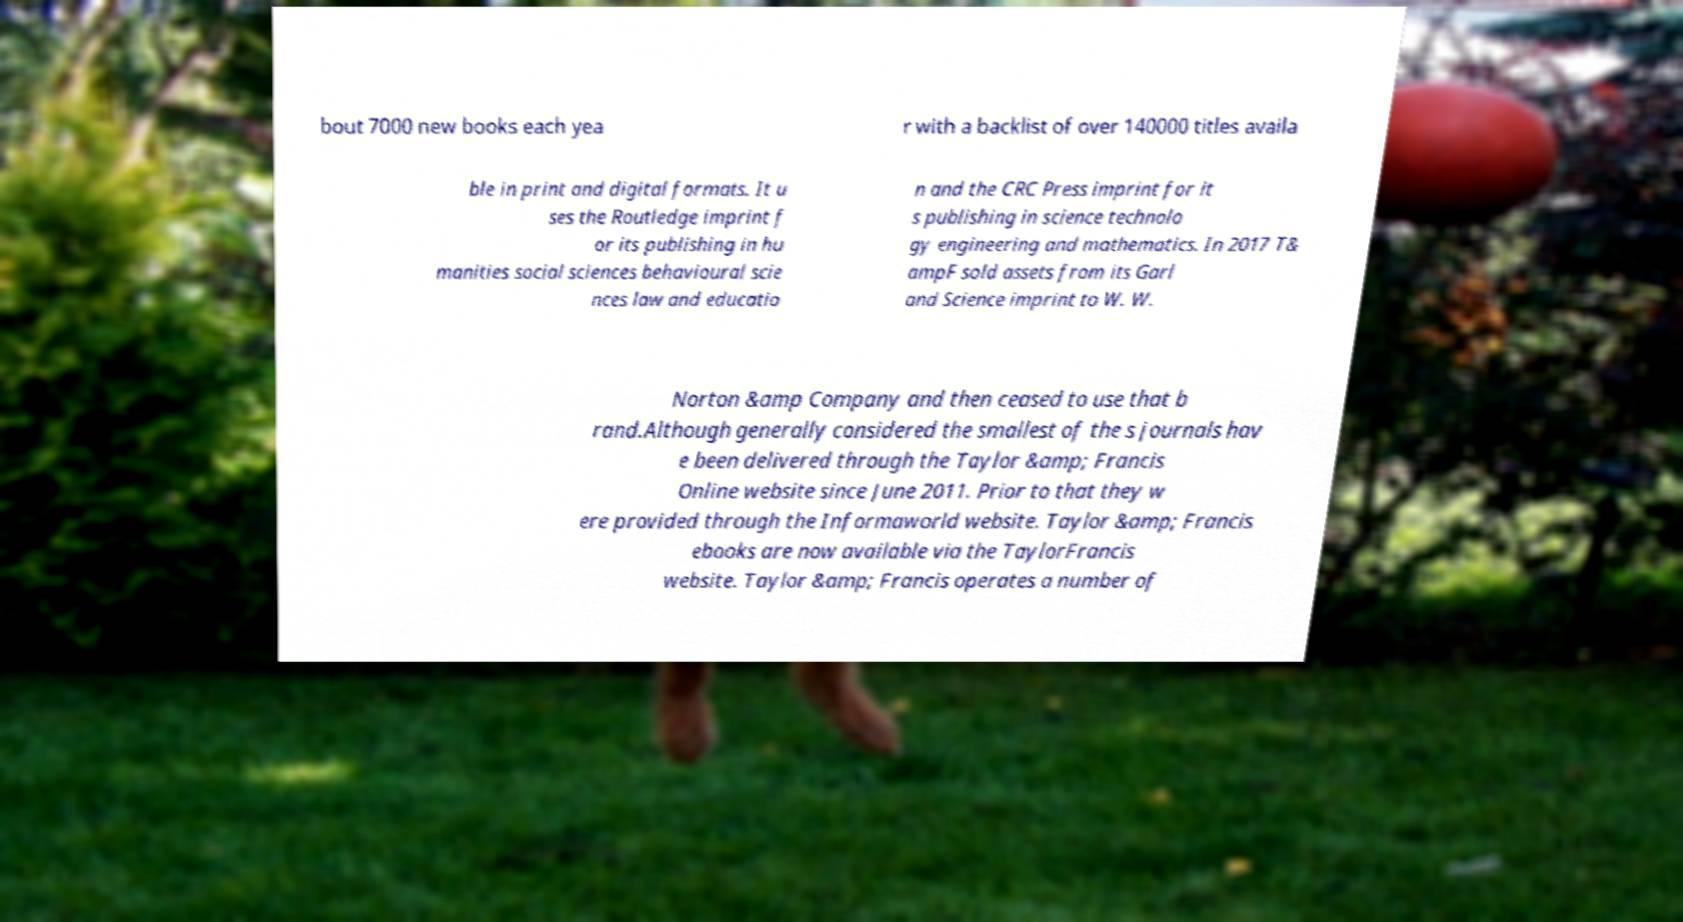Could you extract and type out the text from this image? bout 7000 new books each yea r with a backlist of over 140000 titles availa ble in print and digital formats. It u ses the Routledge imprint f or its publishing in hu manities social sciences behavioural scie nces law and educatio n and the CRC Press imprint for it s publishing in science technolo gy engineering and mathematics. In 2017 T& ampF sold assets from its Garl and Science imprint to W. W. Norton &amp Company and then ceased to use that b rand.Although generally considered the smallest of the s journals hav e been delivered through the Taylor &amp; Francis Online website since June 2011. Prior to that they w ere provided through the Informaworld website. Taylor &amp; Francis ebooks are now available via the TaylorFrancis website. Taylor &amp; Francis operates a number of 